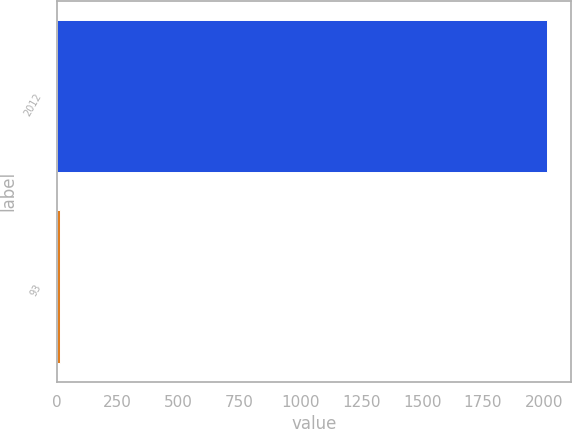Convert chart to OTSL. <chart><loc_0><loc_0><loc_500><loc_500><bar_chart><fcel>2012<fcel>93<nl><fcel>2011<fcel>11.9<nl></chart> 